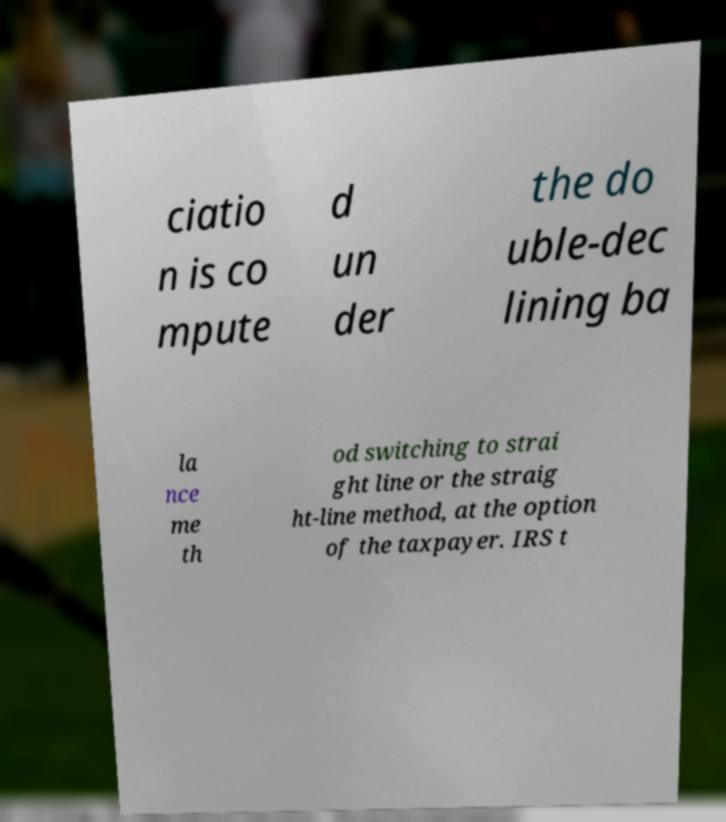Could you extract and type out the text from this image? ciatio n is co mpute d un der the do uble-dec lining ba la nce me th od switching to strai ght line or the straig ht-line method, at the option of the taxpayer. IRS t 